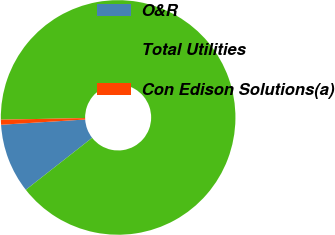Convert chart to OTSL. <chart><loc_0><loc_0><loc_500><loc_500><pie_chart><fcel>O&R<fcel>Total Utilities<fcel>Con Edison Solutions(a)<nl><fcel>9.59%<fcel>89.73%<fcel>0.69%<nl></chart> 